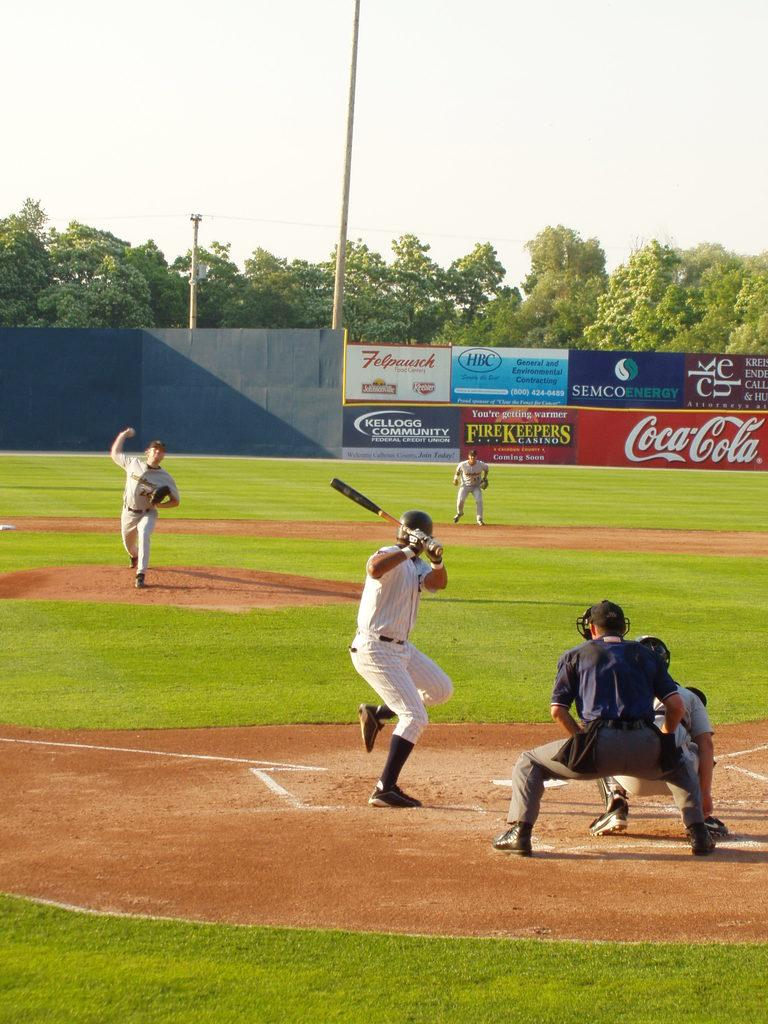Provide a one-sentence caption for the provided image. Advertisements on a ball field's wall include Coca Cola, FireKeepers Casino, and Semco Energy. 